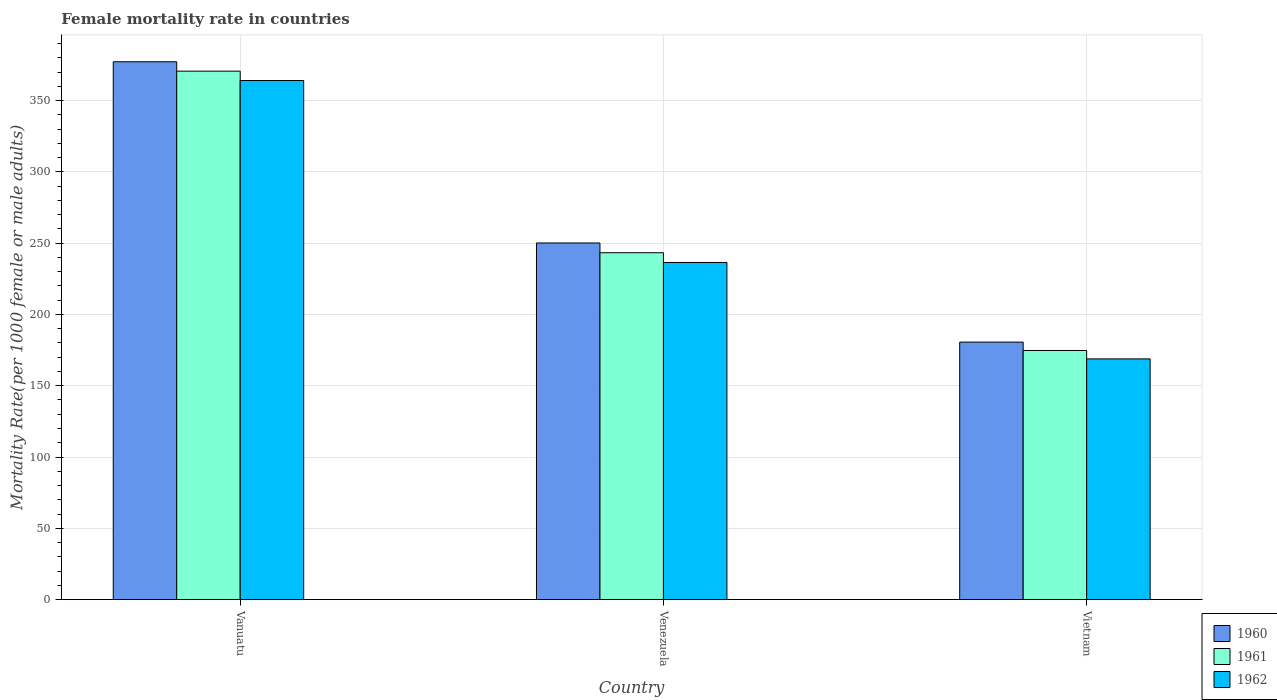How many different coloured bars are there?
Give a very brief answer. 3. How many groups of bars are there?
Offer a terse response. 3. Are the number of bars on each tick of the X-axis equal?
Offer a very short reply. Yes. How many bars are there on the 3rd tick from the left?
Keep it short and to the point. 3. What is the label of the 1st group of bars from the left?
Your answer should be compact. Vanuatu. In how many cases, is the number of bars for a given country not equal to the number of legend labels?
Ensure brevity in your answer.  0. What is the female mortality rate in 1961 in Vanuatu?
Offer a very short reply. 370.66. Across all countries, what is the maximum female mortality rate in 1960?
Give a very brief answer. 377.24. Across all countries, what is the minimum female mortality rate in 1962?
Offer a very short reply. 168.82. In which country was the female mortality rate in 1961 maximum?
Your answer should be very brief. Vanuatu. In which country was the female mortality rate in 1960 minimum?
Your answer should be very brief. Vietnam. What is the total female mortality rate in 1962 in the graph?
Ensure brevity in your answer.  769.36. What is the difference between the female mortality rate in 1960 in Vanuatu and that in Venezuela?
Keep it short and to the point. 127.11. What is the difference between the female mortality rate in 1961 in Venezuela and the female mortality rate in 1962 in Vanuatu?
Keep it short and to the point. -120.78. What is the average female mortality rate in 1961 per country?
Provide a short and direct response. 262.89. What is the difference between the female mortality rate of/in 1962 and female mortality rate of/in 1961 in Vietnam?
Provide a short and direct response. -5.89. In how many countries, is the female mortality rate in 1962 greater than 40?
Ensure brevity in your answer.  3. What is the ratio of the female mortality rate in 1960 in Vanuatu to that in Venezuela?
Your answer should be very brief. 1.51. What is the difference between the highest and the second highest female mortality rate in 1960?
Your answer should be compact. 127.11. What is the difference between the highest and the lowest female mortality rate in 1962?
Your response must be concise. 195.25. In how many countries, is the female mortality rate in 1960 greater than the average female mortality rate in 1960 taken over all countries?
Your answer should be very brief. 1. What does the 3rd bar from the left in Venezuela represents?
Offer a very short reply. 1962. Are all the bars in the graph horizontal?
Give a very brief answer. No. What is the difference between two consecutive major ticks on the Y-axis?
Your answer should be very brief. 50. Are the values on the major ticks of Y-axis written in scientific E-notation?
Your response must be concise. No. Does the graph contain grids?
Provide a short and direct response. Yes. How are the legend labels stacked?
Offer a terse response. Vertical. What is the title of the graph?
Your response must be concise. Female mortality rate in countries. What is the label or title of the Y-axis?
Make the answer very short. Mortality Rate(per 1000 female or male adults). What is the Mortality Rate(per 1000 female or male adults) of 1960 in Vanuatu?
Provide a short and direct response. 377.24. What is the Mortality Rate(per 1000 female or male adults) in 1961 in Vanuatu?
Your response must be concise. 370.66. What is the Mortality Rate(per 1000 female or male adults) in 1962 in Vanuatu?
Give a very brief answer. 364.07. What is the Mortality Rate(per 1000 female or male adults) in 1960 in Venezuela?
Offer a very short reply. 250.12. What is the Mortality Rate(per 1000 female or male adults) in 1961 in Venezuela?
Your response must be concise. 243.29. What is the Mortality Rate(per 1000 female or male adults) of 1962 in Venezuela?
Your answer should be compact. 236.46. What is the Mortality Rate(per 1000 female or male adults) in 1960 in Vietnam?
Keep it short and to the point. 180.6. What is the Mortality Rate(per 1000 female or male adults) in 1961 in Vietnam?
Your answer should be compact. 174.71. What is the Mortality Rate(per 1000 female or male adults) of 1962 in Vietnam?
Ensure brevity in your answer.  168.82. Across all countries, what is the maximum Mortality Rate(per 1000 female or male adults) in 1960?
Provide a succinct answer. 377.24. Across all countries, what is the maximum Mortality Rate(per 1000 female or male adults) in 1961?
Give a very brief answer. 370.66. Across all countries, what is the maximum Mortality Rate(per 1000 female or male adults) in 1962?
Provide a succinct answer. 364.07. Across all countries, what is the minimum Mortality Rate(per 1000 female or male adults) in 1960?
Ensure brevity in your answer.  180.6. Across all countries, what is the minimum Mortality Rate(per 1000 female or male adults) in 1961?
Keep it short and to the point. 174.71. Across all countries, what is the minimum Mortality Rate(per 1000 female or male adults) of 1962?
Provide a succinct answer. 168.82. What is the total Mortality Rate(per 1000 female or male adults) in 1960 in the graph?
Offer a terse response. 807.96. What is the total Mortality Rate(per 1000 female or male adults) of 1961 in the graph?
Your answer should be very brief. 788.66. What is the total Mortality Rate(per 1000 female or male adults) of 1962 in the graph?
Give a very brief answer. 769.36. What is the difference between the Mortality Rate(per 1000 female or male adults) of 1960 in Vanuatu and that in Venezuela?
Ensure brevity in your answer.  127.11. What is the difference between the Mortality Rate(per 1000 female or male adults) in 1961 in Vanuatu and that in Venezuela?
Offer a terse response. 127.36. What is the difference between the Mortality Rate(per 1000 female or male adults) of 1962 in Vanuatu and that in Venezuela?
Provide a short and direct response. 127.61. What is the difference between the Mortality Rate(per 1000 female or male adults) of 1960 in Vanuatu and that in Vietnam?
Give a very brief answer. 196.63. What is the difference between the Mortality Rate(per 1000 female or male adults) of 1961 in Vanuatu and that in Vietnam?
Provide a short and direct response. 195.94. What is the difference between the Mortality Rate(per 1000 female or male adults) of 1962 in Vanuatu and that in Vietnam?
Ensure brevity in your answer.  195.25. What is the difference between the Mortality Rate(per 1000 female or male adults) in 1960 in Venezuela and that in Vietnam?
Offer a terse response. 69.52. What is the difference between the Mortality Rate(per 1000 female or male adults) in 1961 in Venezuela and that in Vietnam?
Keep it short and to the point. 68.58. What is the difference between the Mortality Rate(per 1000 female or male adults) of 1962 in Venezuela and that in Vietnam?
Provide a short and direct response. 67.64. What is the difference between the Mortality Rate(per 1000 female or male adults) in 1960 in Vanuatu and the Mortality Rate(per 1000 female or male adults) in 1961 in Venezuela?
Keep it short and to the point. 133.94. What is the difference between the Mortality Rate(per 1000 female or male adults) of 1960 in Vanuatu and the Mortality Rate(per 1000 female or male adults) of 1962 in Venezuela?
Offer a terse response. 140.78. What is the difference between the Mortality Rate(per 1000 female or male adults) of 1961 in Vanuatu and the Mortality Rate(per 1000 female or male adults) of 1962 in Venezuela?
Give a very brief answer. 134.2. What is the difference between the Mortality Rate(per 1000 female or male adults) in 1960 in Vanuatu and the Mortality Rate(per 1000 female or male adults) in 1961 in Vietnam?
Offer a very short reply. 202.52. What is the difference between the Mortality Rate(per 1000 female or male adults) in 1960 in Vanuatu and the Mortality Rate(per 1000 female or male adults) in 1962 in Vietnam?
Provide a short and direct response. 208.41. What is the difference between the Mortality Rate(per 1000 female or male adults) of 1961 in Vanuatu and the Mortality Rate(per 1000 female or male adults) of 1962 in Vietnam?
Provide a succinct answer. 201.83. What is the difference between the Mortality Rate(per 1000 female or male adults) in 1960 in Venezuela and the Mortality Rate(per 1000 female or male adults) in 1961 in Vietnam?
Your answer should be very brief. 75.41. What is the difference between the Mortality Rate(per 1000 female or male adults) of 1960 in Venezuela and the Mortality Rate(per 1000 female or male adults) of 1962 in Vietnam?
Keep it short and to the point. 81.3. What is the difference between the Mortality Rate(per 1000 female or male adults) of 1961 in Venezuela and the Mortality Rate(per 1000 female or male adults) of 1962 in Vietnam?
Your response must be concise. 74.47. What is the average Mortality Rate(per 1000 female or male adults) of 1960 per country?
Ensure brevity in your answer.  269.32. What is the average Mortality Rate(per 1000 female or male adults) of 1961 per country?
Offer a terse response. 262.89. What is the average Mortality Rate(per 1000 female or male adults) of 1962 per country?
Make the answer very short. 256.45. What is the difference between the Mortality Rate(per 1000 female or male adults) in 1960 and Mortality Rate(per 1000 female or male adults) in 1961 in Vanuatu?
Provide a short and direct response. 6.58. What is the difference between the Mortality Rate(per 1000 female or male adults) of 1960 and Mortality Rate(per 1000 female or male adults) of 1962 in Vanuatu?
Provide a succinct answer. 13.16. What is the difference between the Mortality Rate(per 1000 female or male adults) of 1961 and Mortality Rate(per 1000 female or male adults) of 1962 in Vanuatu?
Ensure brevity in your answer.  6.58. What is the difference between the Mortality Rate(per 1000 female or male adults) of 1960 and Mortality Rate(per 1000 female or male adults) of 1961 in Venezuela?
Offer a very short reply. 6.83. What is the difference between the Mortality Rate(per 1000 female or male adults) in 1960 and Mortality Rate(per 1000 female or male adults) in 1962 in Venezuela?
Make the answer very short. 13.66. What is the difference between the Mortality Rate(per 1000 female or male adults) of 1961 and Mortality Rate(per 1000 female or male adults) of 1962 in Venezuela?
Give a very brief answer. 6.83. What is the difference between the Mortality Rate(per 1000 female or male adults) in 1960 and Mortality Rate(per 1000 female or male adults) in 1961 in Vietnam?
Your response must be concise. 5.89. What is the difference between the Mortality Rate(per 1000 female or male adults) in 1960 and Mortality Rate(per 1000 female or male adults) in 1962 in Vietnam?
Provide a short and direct response. 11.78. What is the difference between the Mortality Rate(per 1000 female or male adults) in 1961 and Mortality Rate(per 1000 female or male adults) in 1962 in Vietnam?
Keep it short and to the point. 5.89. What is the ratio of the Mortality Rate(per 1000 female or male adults) in 1960 in Vanuatu to that in Venezuela?
Ensure brevity in your answer.  1.51. What is the ratio of the Mortality Rate(per 1000 female or male adults) in 1961 in Vanuatu to that in Venezuela?
Ensure brevity in your answer.  1.52. What is the ratio of the Mortality Rate(per 1000 female or male adults) in 1962 in Vanuatu to that in Venezuela?
Offer a very short reply. 1.54. What is the ratio of the Mortality Rate(per 1000 female or male adults) in 1960 in Vanuatu to that in Vietnam?
Make the answer very short. 2.09. What is the ratio of the Mortality Rate(per 1000 female or male adults) of 1961 in Vanuatu to that in Vietnam?
Provide a succinct answer. 2.12. What is the ratio of the Mortality Rate(per 1000 female or male adults) in 1962 in Vanuatu to that in Vietnam?
Provide a succinct answer. 2.16. What is the ratio of the Mortality Rate(per 1000 female or male adults) of 1960 in Venezuela to that in Vietnam?
Keep it short and to the point. 1.38. What is the ratio of the Mortality Rate(per 1000 female or male adults) of 1961 in Venezuela to that in Vietnam?
Give a very brief answer. 1.39. What is the ratio of the Mortality Rate(per 1000 female or male adults) of 1962 in Venezuela to that in Vietnam?
Offer a terse response. 1.4. What is the difference between the highest and the second highest Mortality Rate(per 1000 female or male adults) in 1960?
Your answer should be compact. 127.11. What is the difference between the highest and the second highest Mortality Rate(per 1000 female or male adults) in 1961?
Offer a very short reply. 127.36. What is the difference between the highest and the second highest Mortality Rate(per 1000 female or male adults) in 1962?
Provide a succinct answer. 127.61. What is the difference between the highest and the lowest Mortality Rate(per 1000 female or male adults) of 1960?
Keep it short and to the point. 196.63. What is the difference between the highest and the lowest Mortality Rate(per 1000 female or male adults) in 1961?
Provide a succinct answer. 195.94. What is the difference between the highest and the lowest Mortality Rate(per 1000 female or male adults) in 1962?
Your answer should be compact. 195.25. 